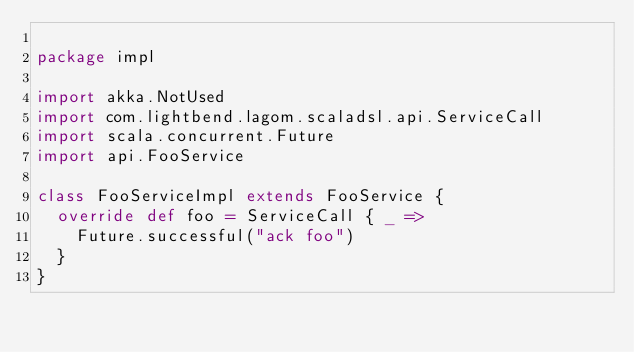<code> <loc_0><loc_0><loc_500><loc_500><_Scala_>
package impl

import akka.NotUsed
import com.lightbend.lagom.scaladsl.api.ServiceCall
import scala.concurrent.Future
import api.FooService

class FooServiceImpl extends FooService {
  override def foo = ServiceCall { _ =>
    Future.successful("ack foo")
  }
}
</code> 